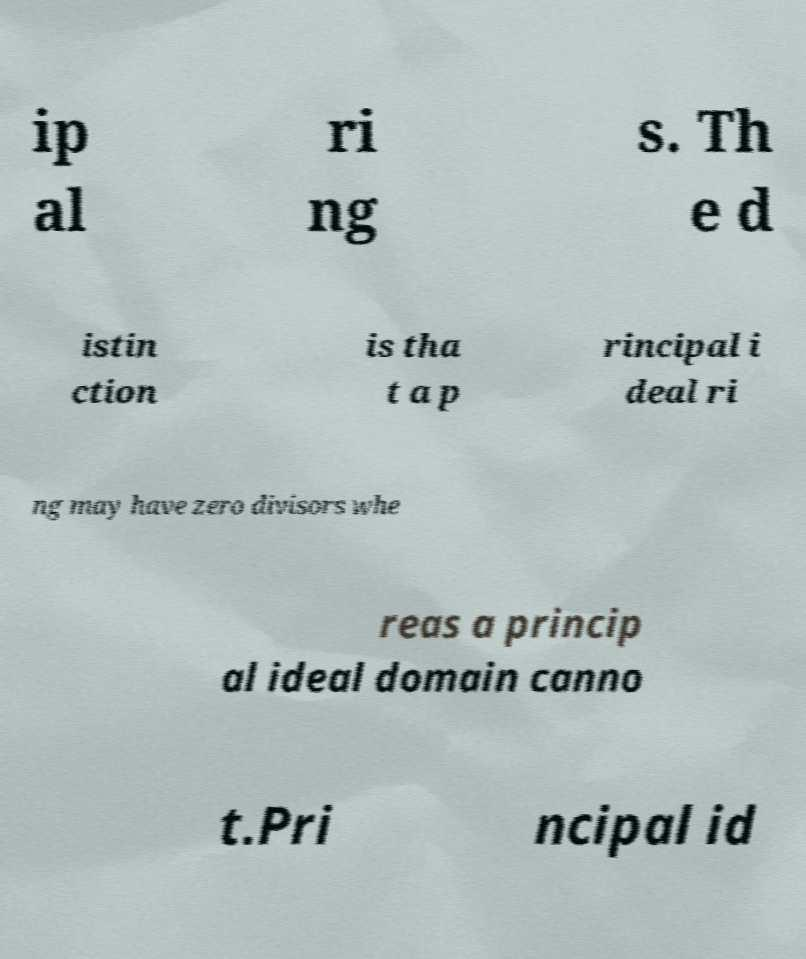Can you accurately transcribe the text from the provided image for me? ip al ri ng s. Th e d istin ction is tha t a p rincipal i deal ri ng may have zero divisors whe reas a princip al ideal domain canno t.Pri ncipal id 